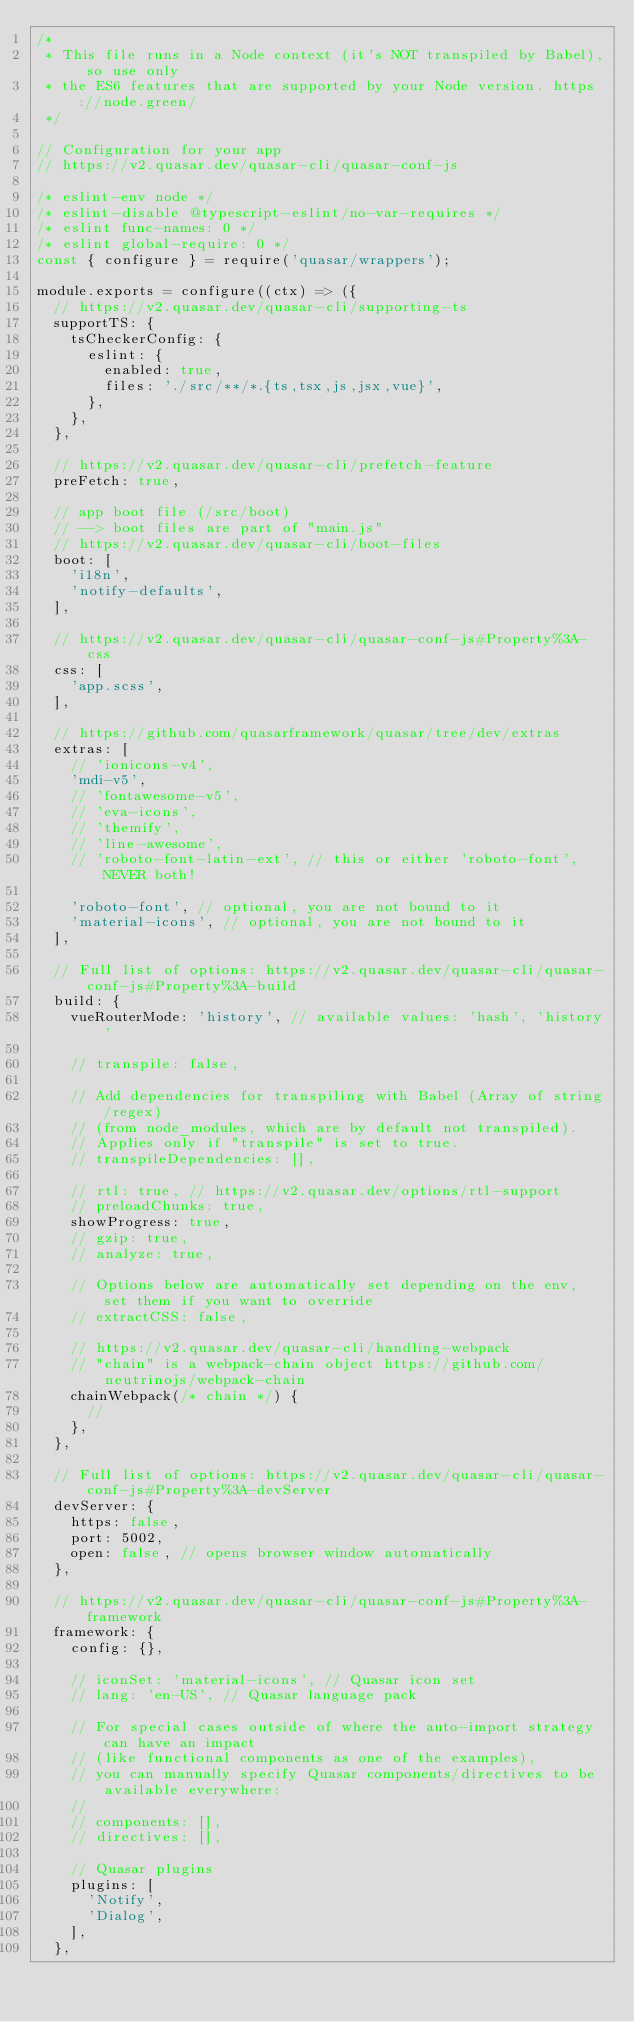Convert code to text. <code><loc_0><loc_0><loc_500><loc_500><_JavaScript_>/*
 * This file runs in a Node context (it's NOT transpiled by Babel), so use only
 * the ES6 features that are supported by your Node version. https://node.green/
 */

// Configuration for your app
// https://v2.quasar.dev/quasar-cli/quasar-conf-js

/* eslint-env node */
/* eslint-disable @typescript-eslint/no-var-requires */
/* eslint func-names: 0 */
/* eslint global-require: 0 */
const { configure } = require('quasar/wrappers');

module.exports = configure((ctx) => ({
  // https://v2.quasar.dev/quasar-cli/supporting-ts
  supportTS: {
    tsCheckerConfig: {
      eslint: {
        enabled: true,
        files: './src/**/*.{ts,tsx,js,jsx,vue}',
      },
    },
  },

  // https://v2.quasar.dev/quasar-cli/prefetch-feature
  preFetch: true,

  // app boot file (/src/boot)
  // --> boot files are part of "main.js"
  // https://v2.quasar.dev/quasar-cli/boot-files
  boot: [
    'i18n',
    'notify-defaults',
  ],

  // https://v2.quasar.dev/quasar-cli/quasar-conf-js#Property%3A-css
  css: [
    'app.scss',
  ],

  // https://github.com/quasarframework/quasar/tree/dev/extras
  extras: [
    // 'ionicons-v4',
    'mdi-v5',
    // 'fontawesome-v5',
    // 'eva-icons',
    // 'themify',
    // 'line-awesome',
    // 'roboto-font-latin-ext', // this or either 'roboto-font', NEVER both!

    'roboto-font', // optional, you are not bound to it
    'material-icons', // optional, you are not bound to it
  ],

  // Full list of options: https://v2.quasar.dev/quasar-cli/quasar-conf-js#Property%3A-build
  build: {
    vueRouterMode: 'history', // available values: 'hash', 'history'

    // transpile: false,

    // Add dependencies for transpiling with Babel (Array of string/regex)
    // (from node_modules, which are by default not transpiled).
    // Applies only if "transpile" is set to true.
    // transpileDependencies: [],

    // rtl: true, // https://v2.quasar.dev/options/rtl-support
    // preloadChunks: true,
    showProgress: true,
    // gzip: true,
    // analyze: true,

    // Options below are automatically set depending on the env, set them if you want to override
    // extractCSS: false,

    // https://v2.quasar.dev/quasar-cli/handling-webpack
    // "chain" is a webpack-chain object https://github.com/neutrinojs/webpack-chain
    chainWebpack(/* chain */) {
      //
    },
  },

  // Full list of options: https://v2.quasar.dev/quasar-cli/quasar-conf-js#Property%3A-devServer
  devServer: {
    https: false,
    port: 5002,
    open: false, // opens browser window automatically
  },

  // https://v2.quasar.dev/quasar-cli/quasar-conf-js#Property%3A-framework
  framework: {
    config: {},

    // iconSet: 'material-icons', // Quasar icon set
    // lang: 'en-US', // Quasar language pack

    // For special cases outside of where the auto-import strategy can have an impact
    // (like functional components as one of the examples),
    // you can manually specify Quasar components/directives to be available everywhere:
    //
    // components: [],
    // directives: [],

    // Quasar plugins
    plugins: [
      'Notify',
      'Dialog',
    ],
  },
</code> 